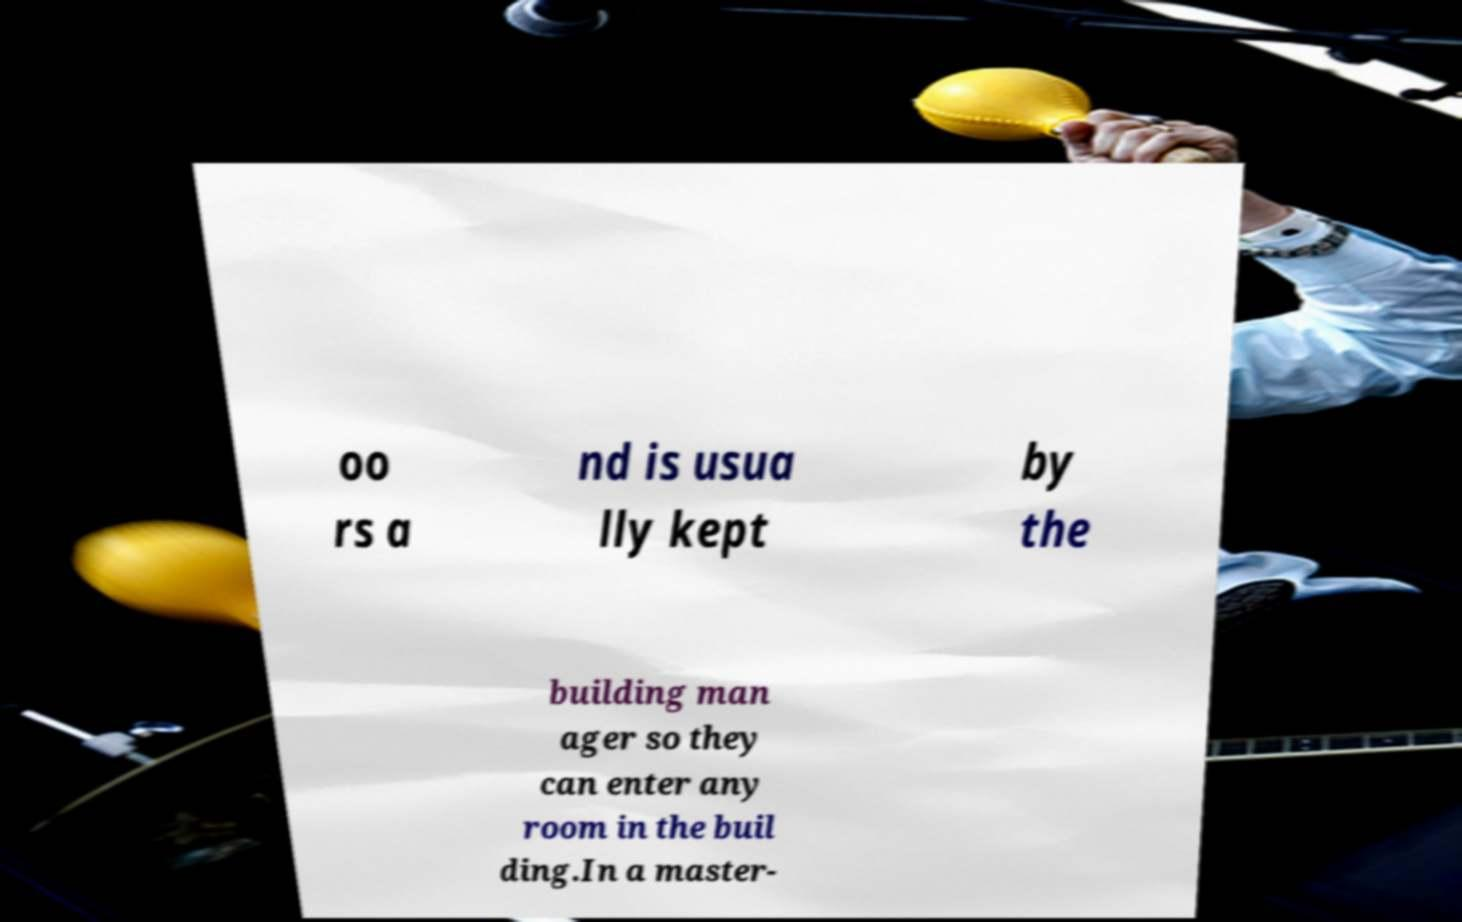Could you assist in decoding the text presented in this image and type it out clearly? oo rs a nd is usua lly kept by the building man ager so they can enter any room in the buil ding.In a master- 